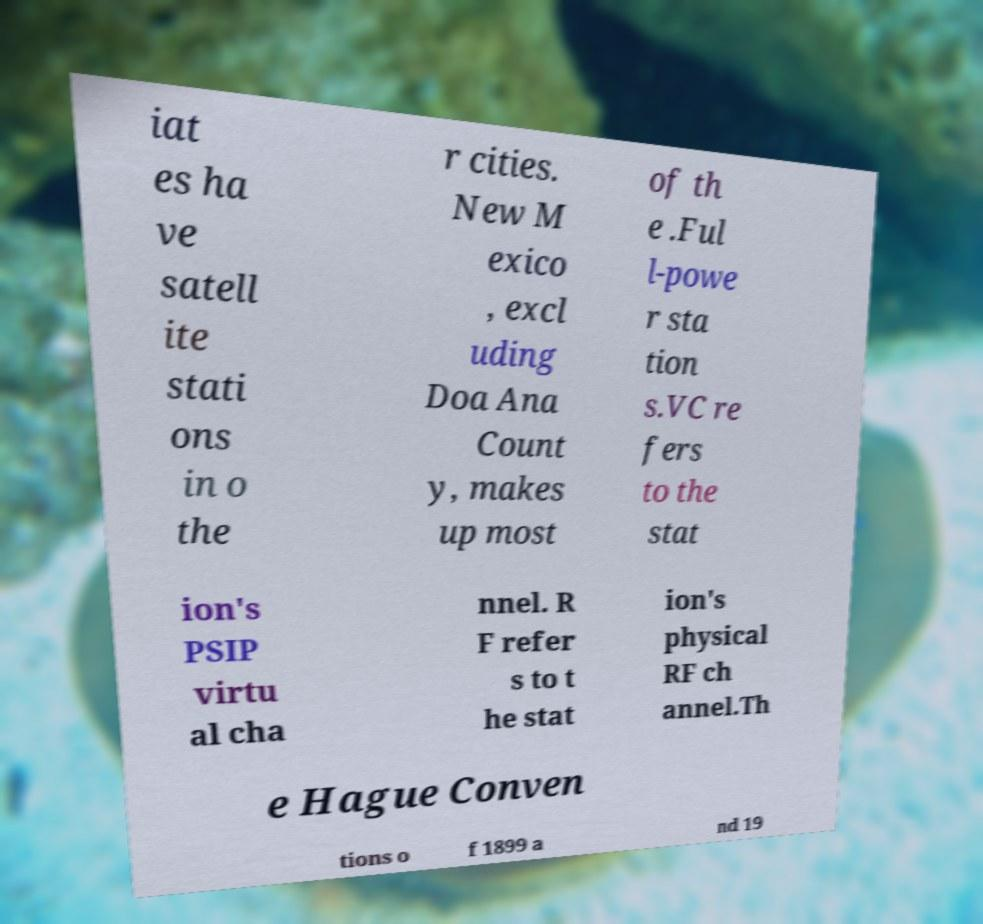What messages or text are displayed in this image? I need them in a readable, typed format. iat es ha ve satell ite stati ons in o the r cities. New M exico , excl uding Doa Ana Count y, makes up most of th e .Ful l-powe r sta tion s.VC re fers to the stat ion's PSIP virtu al cha nnel. R F refer s to t he stat ion's physical RF ch annel.Th e Hague Conven tions o f 1899 a nd 19 